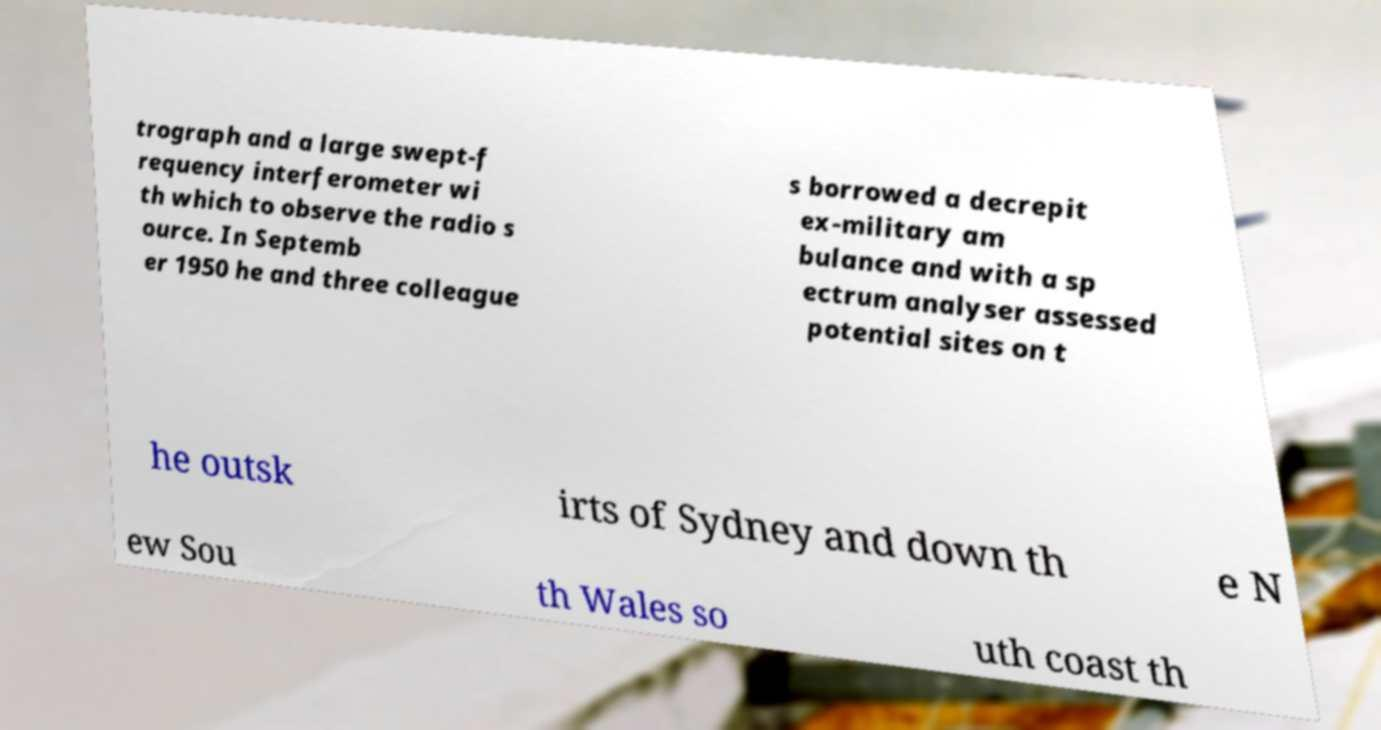Could you assist in decoding the text presented in this image and type it out clearly? trograph and a large swept-f requency interferometer wi th which to observe the radio s ource. In Septemb er 1950 he and three colleague s borrowed a decrepit ex-military am bulance and with a sp ectrum analyser assessed potential sites on t he outsk irts of Sydney and down th e N ew Sou th Wales so uth coast th 